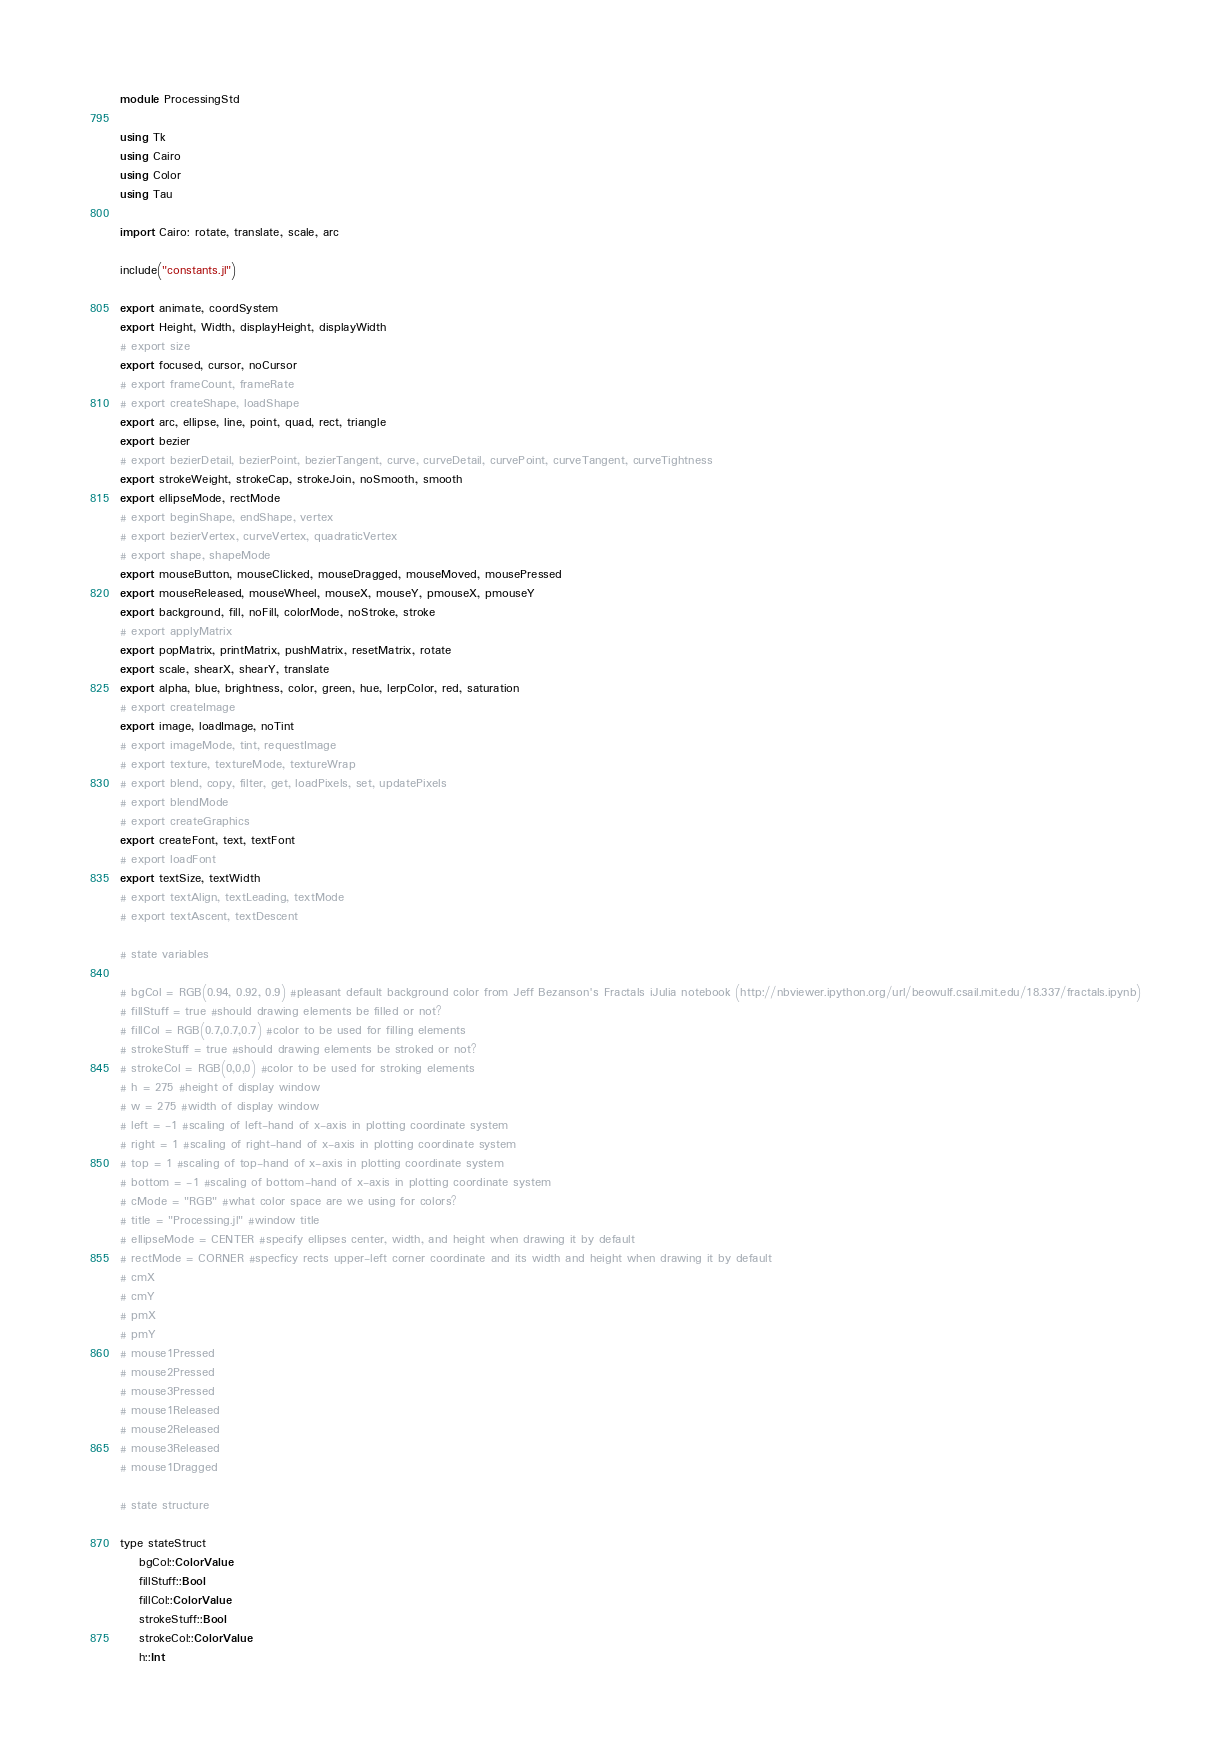<code> <loc_0><loc_0><loc_500><loc_500><_Julia_>module ProcessingStd

using Tk
using Cairo
using Color
using Tau

import Cairo: rotate, translate, scale, arc

include("constants.jl")

export animate, coordSystem
export Height, Width, displayHeight, displayWidth
# export size
export focused, cursor, noCursor
# export frameCount, frameRate
# export createShape, loadShape
export arc, ellipse, line, point, quad, rect, triangle
export bezier
# export bezierDetail, bezierPoint, bezierTangent, curve, curveDetail, curvePoint, curveTangent, curveTightness
export strokeWeight, strokeCap, strokeJoin, noSmooth, smooth
export ellipseMode, rectMode
# export beginShape, endShape, vertex
# export bezierVertex, curveVertex, quadraticVertex
# export shape, shapeMode
export mouseButton, mouseClicked, mouseDragged, mouseMoved, mousePressed
export mouseReleased, mouseWheel, mouseX, mouseY, pmouseX, pmouseY
export background, fill, noFill, colorMode, noStroke, stroke
# export applyMatrix
export popMatrix, printMatrix, pushMatrix, resetMatrix, rotate
export scale, shearX, shearY, translate
export alpha, blue, brightness, color, green, hue, lerpColor, red, saturation
# export createImage
export image, loadImage, noTint
# export imageMode, tint, requestImage
# export texture, textureMode, textureWrap
# export blend, copy, filter, get, loadPixels, set, updatePixels
# export blendMode
# export createGraphics
export createFont, text, textFont
# export loadFont
export textSize, textWidth
# export textAlign, textLeading, textMode
# export textAscent, textDescent

# state variables

# bgCol = RGB(0.94, 0.92, 0.9) #pleasant default background color from Jeff Bezanson's Fractals iJulia notebook (http://nbviewer.ipython.org/url/beowulf.csail.mit.edu/18.337/fractals.ipynb)
# fillStuff = true #should drawing elements be filled or not?
# fillCol = RGB(0.7,0.7,0.7) #color to be used for filling elements
# strokeStuff = true #should drawing elements be stroked or not?
# strokeCol = RGB(0,0,0) #color to be used for stroking elements
# h = 275 #height of display window
# w = 275 #width of display window
# left = -1 #scaling of left-hand of x-axis in plotting coordinate system
# right = 1 #scaling of right-hand of x-axis in plotting coordinate system
# top = 1 #scaling of top-hand of x-axis in plotting coordinate system
# bottom = -1 #scaling of bottom-hand of x-axis in plotting coordinate system
# cMode = "RGB" #what color space are we using for colors?
# title = "Processing.jl" #window title
# ellipseMode = CENTER #specify ellipses center, width, and height when drawing it by default
# rectMode = CORNER #specficy rects upper-left corner coordinate and its width and height when drawing it by default
# cmX
# cmY
# pmX
# pmY
# mouse1Pressed
# mouse2Pressed
# mouse3Pressed
# mouse1Released
# mouse2Released
# mouse3Released
# mouse1Dragged

# state structure

type stateStruct
    bgCol::ColorValue
    fillStuff::Bool
    fillCol::ColorValue
    strokeStuff::Bool
    strokeCol::ColorValue
    h::Int</code> 